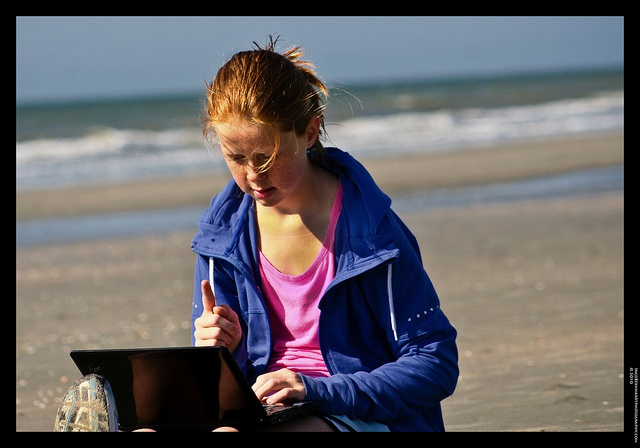Describe the objects in this image and their specific colors. I can see people in black, navy, maroon, and blue tones and laptop in black, maroon, gray, and darkgray tones in this image. 